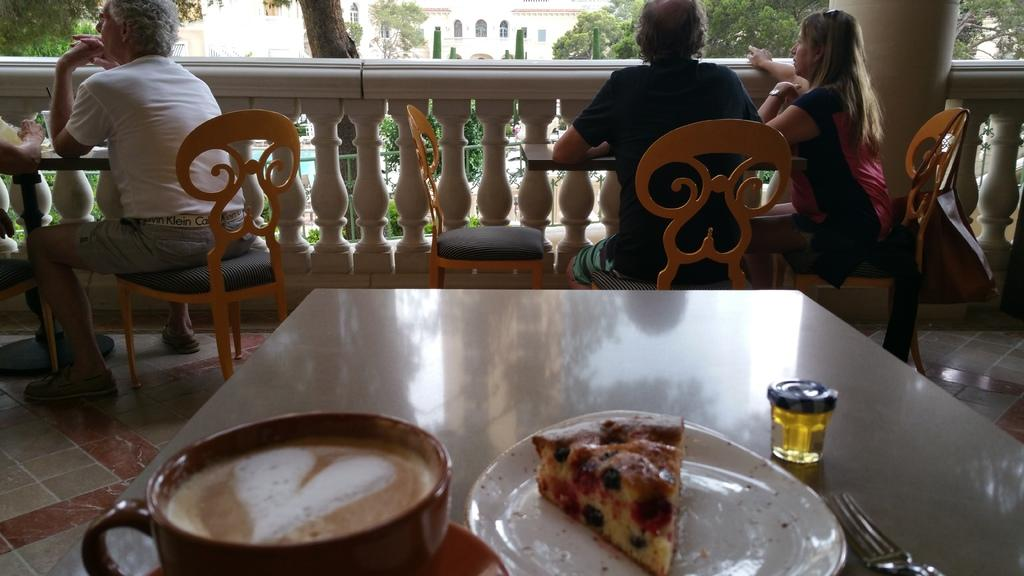Who is the main subject in the image? There is an old man in the image. What is the old man doing in the image? The old man is sitting on a chair. What is in front of the old man? There is a table in front of the old man. What can be found on the table? There is a coffee cup and food in a plate on the table. What utensil is beside the plate on the table? There is a fork beside the plate on the table. Where is the playground located in the image? There is no playground present in the image. What type of yarn is the old man using in the image? There is no yarn present in the image. 